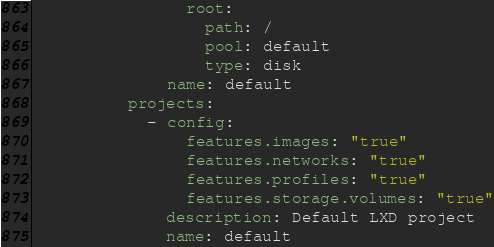<code> <loc_0><loc_0><loc_500><loc_500><_YAML_>                root:
                  path: /
                  pool: default
                  type: disk
              name: default
          projects:
            - config:
                features.images: "true"
                features.networks: "true"
                features.profiles: "true"
                features.storage.volumes: "true"
              description: Default LXD project
              name: default
</code> 